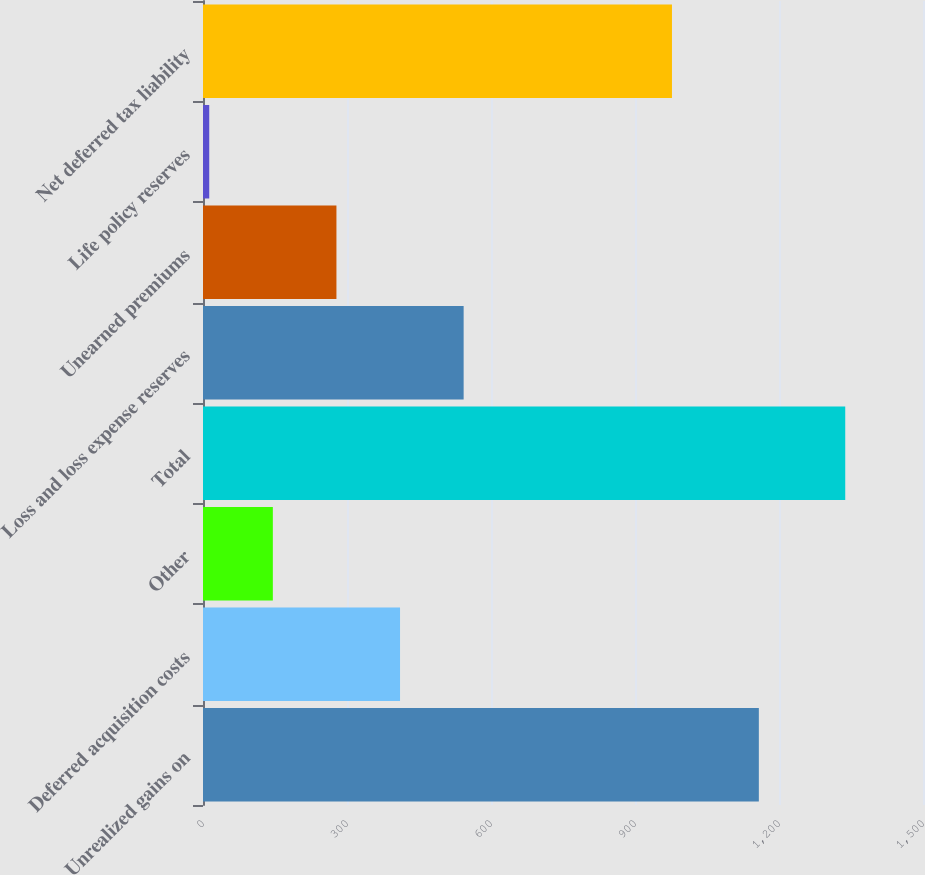Convert chart to OTSL. <chart><loc_0><loc_0><loc_500><loc_500><bar_chart><fcel>Unrealized gains on<fcel>Deferred acquisition costs<fcel>Other<fcel>Total<fcel>Loss and loss expense reserves<fcel>Unearned premiums<fcel>Life policy reserves<fcel>Net deferred tax liability<nl><fcel>1158<fcel>410.5<fcel>145.5<fcel>1338<fcel>543<fcel>278<fcel>13<fcel>977<nl></chart> 